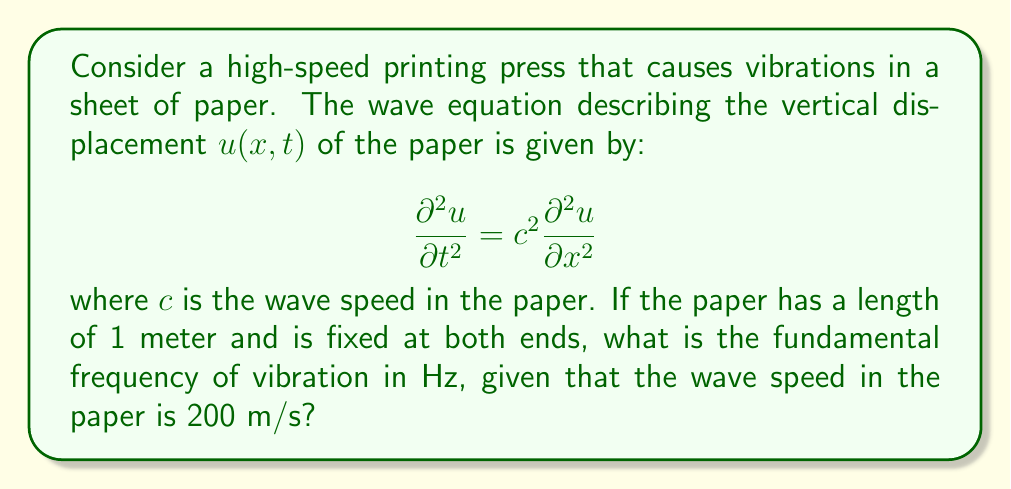Can you answer this question? To solve this problem, we'll follow these steps:

1) For a string (or in this case, a sheet of paper) fixed at both ends, the general solution for the wave equation is:

   $$u(x,t) = \sum_{n=1}^{\infty} A_n \sin(\frac{n\pi x}{L}) \cos(\frac{n\pi c}{L}t)$$

   where $L$ is the length of the paper.

2) The fundamental frequency corresponds to $n=1$. The angular frequency $\omega$ for this mode is:

   $$\omega = \frac{\pi c}{L}$$

3) We're given that $c = 200$ m/s and $L = 1$ m. Let's substitute these values:

   $$\omega = \frac{\pi (200)}{1} = 200\pi \text{ rad/s}$$

4) To convert from angular frequency (rad/s) to frequency (Hz), we use the relation:

   $$f = \frac{\omega}{2\pi}$$

5) Substituting our value for $\omega$:

   $$f = \frac{200\pi}{2\pi} = 100 \text{ Hz}$$

Therefore, the fundamental frequency of vibration is 100 Hz.
Answer: 100 Hz 